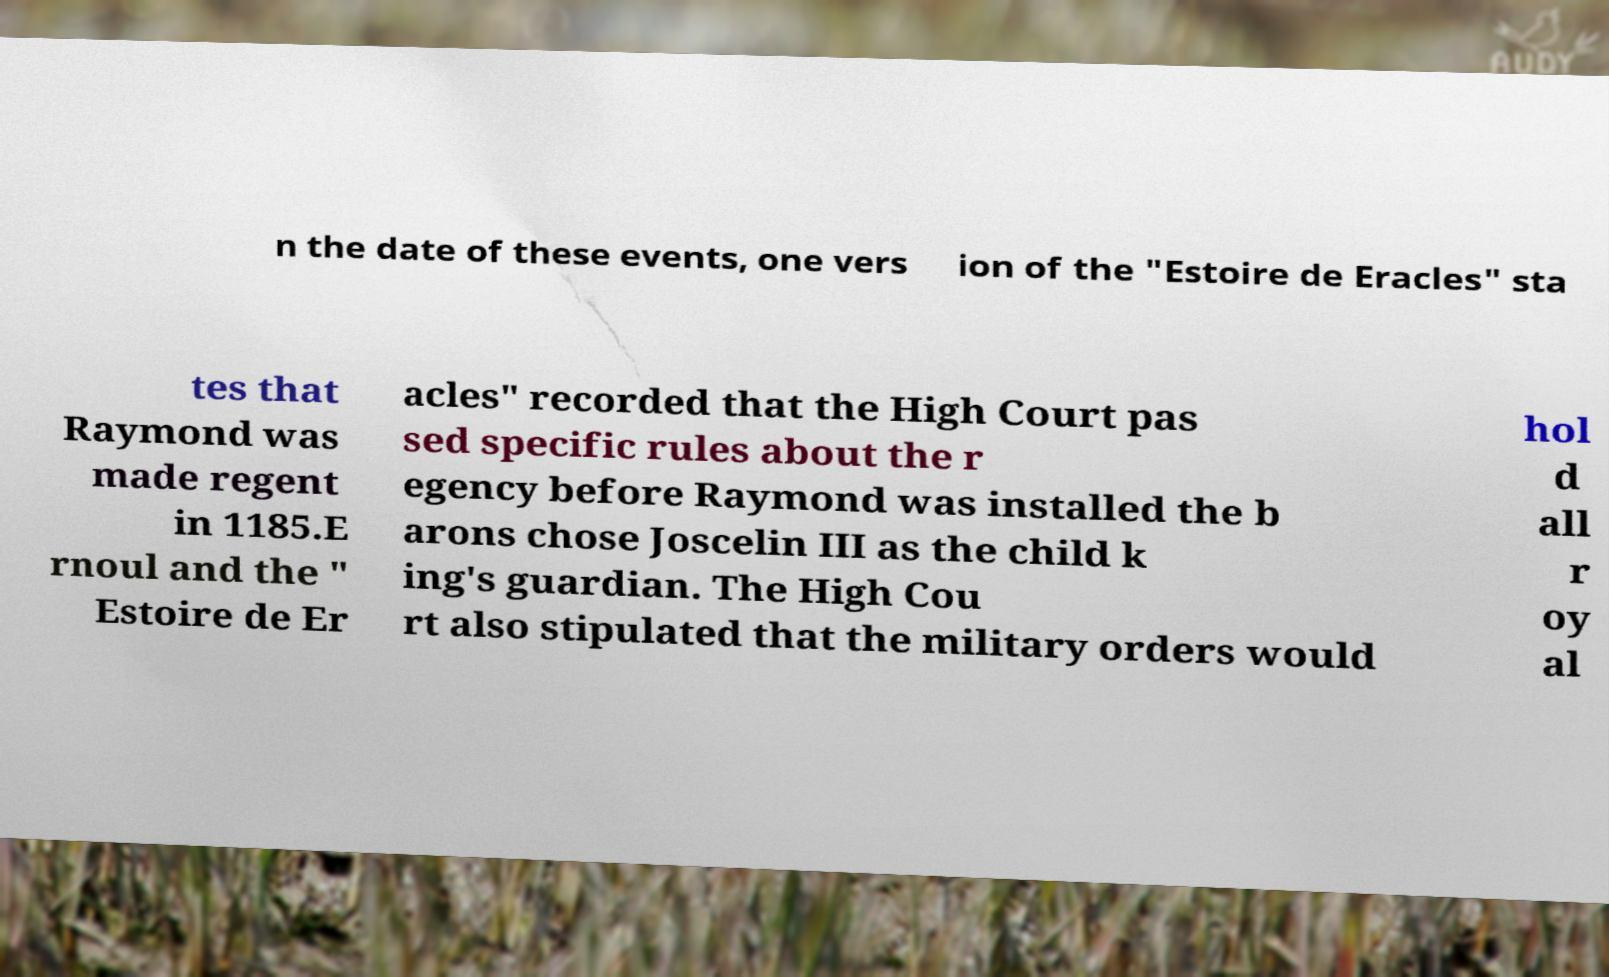I need the written content from this picture converted into text. Can you do that? n the date of these events, one vers ion of the "Estoire de Eracles" sta tes that Raymond was made regent in 1185.E rnoul and the " Estoire de Er acles" recorded that the High Court pas sed specific rules about the r egency before Raymond was installed the b arons chose Joscelin III as the child k ing's guardian. The High Cou rt also stipulated that the military orders would hol d all r oy al 